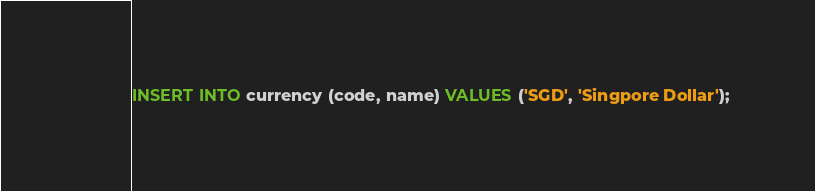Convert code to text. <code><loc_0><loc_0><loc_500><loc_500><_SQL_>INSERT INTO currency (code, name) VALUES ('SGD', 'Singpore Dollar');</code> 